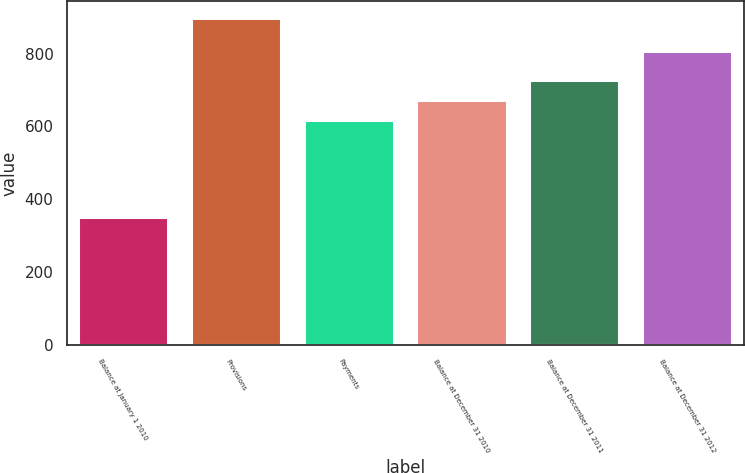<chart> <loc_0><loc_0><loc_500><loc_500><bar_chart><fcel>Balance at January 1 2010<fcel>Provisions<fcel>Payments<fcel>Balance at December 31 2010<fcel>Balance at December 31 2011<fcel>Balance at December 31 2012<nl><fcel>352<fcel>899<fcel>617<fcel>671.7<fcel>726.4<fcel>807<nl></chart> 